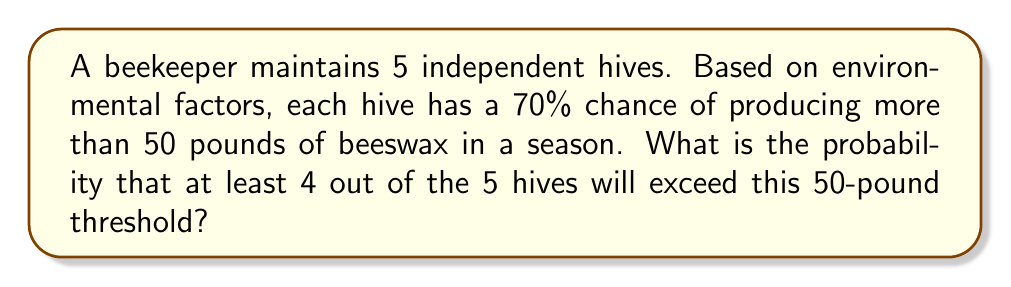Could you help me with this problem? Let's approach this step-by-step using the binomial probability distribution:

1) We can model this scenario as a binomial experiment where:
   - $n = 5$ (number of hives)
   - $p = 0.70$ (probability of success for each hive)
   - We want to find $P(X \geq 4)$ where $X$ is the number of successful hives

2) The probability of exactly 4 successes is:
   $$P(X = 4) = \binom{5}{4} (0.70)^4 (0.30)^1$$

3) The probability of exactly 5 successes is:
   $$P(X = 5) = \binom{5}{5} (0.70)^5 (0.30)^0$$

4) We want $P(X \geq 4) = P(X = 4) + P(X = 5)$

5) Let's calculate each part:
   $$P(X = 4) = 5 \cdot (0.70)^4 \cdot (0.30)^1 = 5 \cdot 0.2401 \cdot 0.30 = 0.36015$$
   $$P(X = 5) = 1 \cdot (0.70)^5 \cdot (0.30)^0 = 0.16807$$

6) Now, we sum these probabilities:
   $$P(X \geq 4) = 0.36015 + 0.16807 = 0.52822$$

Therefore, the probability that at least 4 out of the 5 hives will exceed the 50-pound threshold is approximately 0.52822 or 52.822%.
Answer: 0.52822 